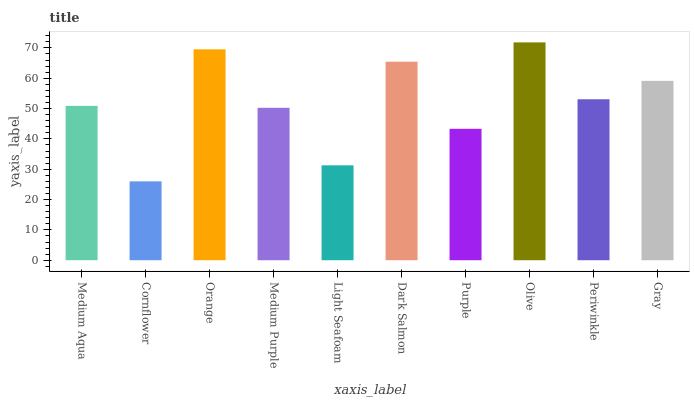Is Cornflower the minimum?
Answer yes or no. Yes. Is Olive the maximum?
Answer yes or no. Yes. Is Orange the minimum?
Answer yes or no. No. Is Orange the maximum?
Answer yes or no. No. Is Orange greater than Cornflower?
Answer yes or no. Yes. Is Cornflower less than Orange?
Answer yes or no. Yes. Is Cornflower greater than Orange?
Answer yes or no. No. Is Orange less than Cornflower?
Answer yes or no. No. Is Periwinkle the high median?
Answer yes or no. Yes. Is Medium Aqua the low median?
Answer yes or no. Yes. Is Medium Aqua the high median?
Answer yes or no. No. Is Periwinkle the low median?
Answer yes or no. No. 